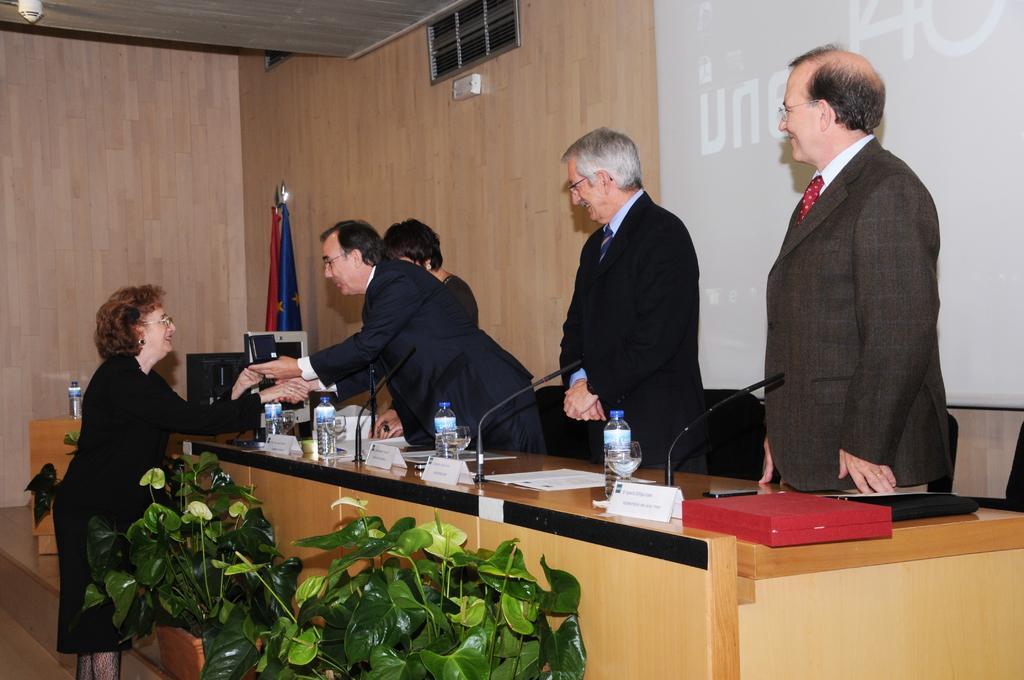In one or two sentences, can you explain what this image depicts? This is a picture taken in a conference. In the center of the picture there is a desk, on the desk there are bottles, mics, files, papers, name plates, desktop and other objects. In the background there are four people standing. In the foreground there are plants and a woman standing. In the center of the background there are flags. On the right there is a screen. 